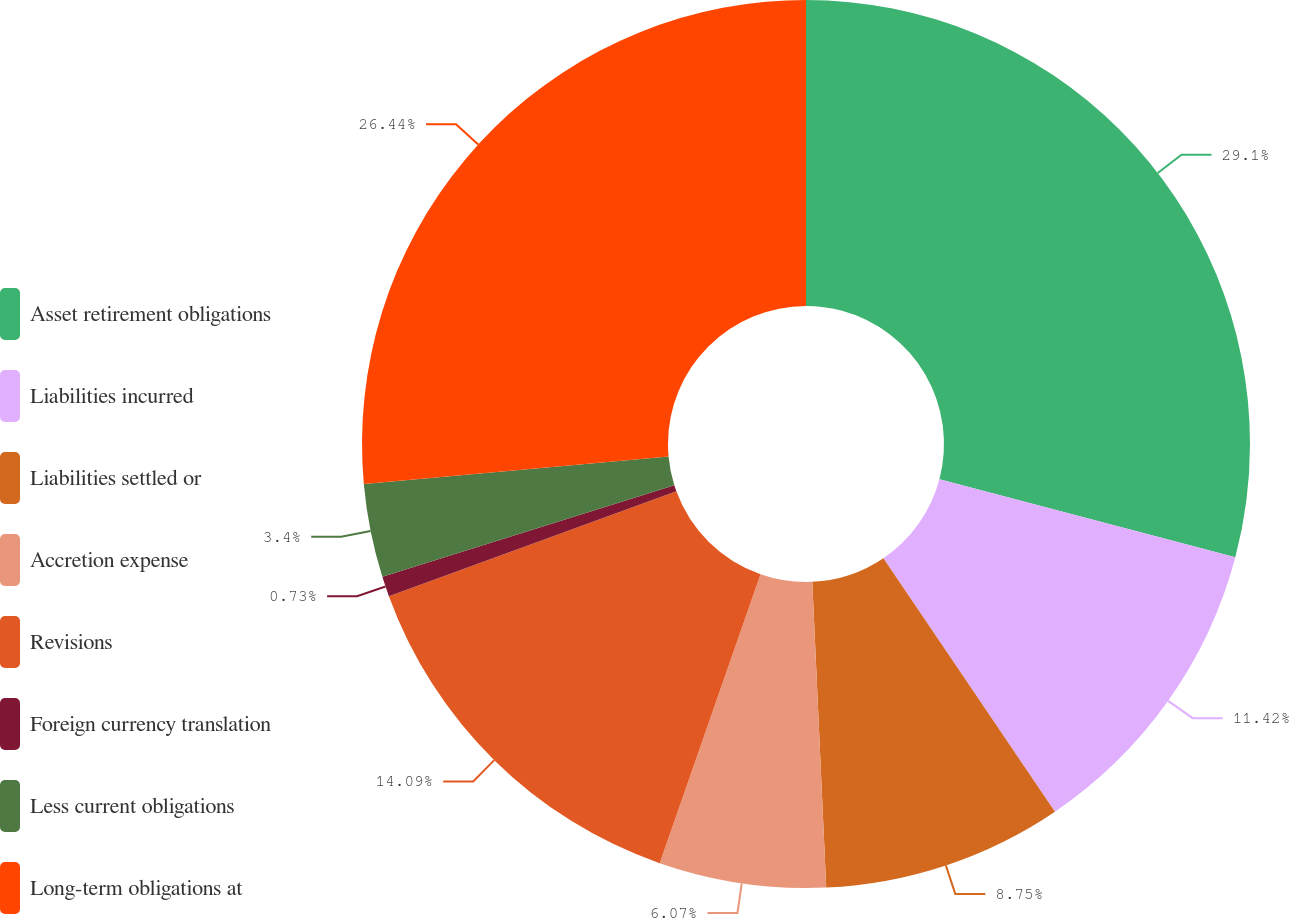Convert chart. <chart><loc_0><loc_0><loc_500><loc_500><pie_chart><fcel>Asset retirement obligations<fcel>Liabilities incurred<fcel>Liabilities settled or<fcel>Accretion expense<fcel>Revisions<fcel>Foreign currency translation<fcel>Less current obligations<fcel>Long-term obligations at<nl><fcel>29.11%<fcel>11.42%<fcel>8.75%<fcel>6.07%<fcel>14.09%<fcel>0.73%<fcel>3.4%<fcel>26.44%<nl></chart> 